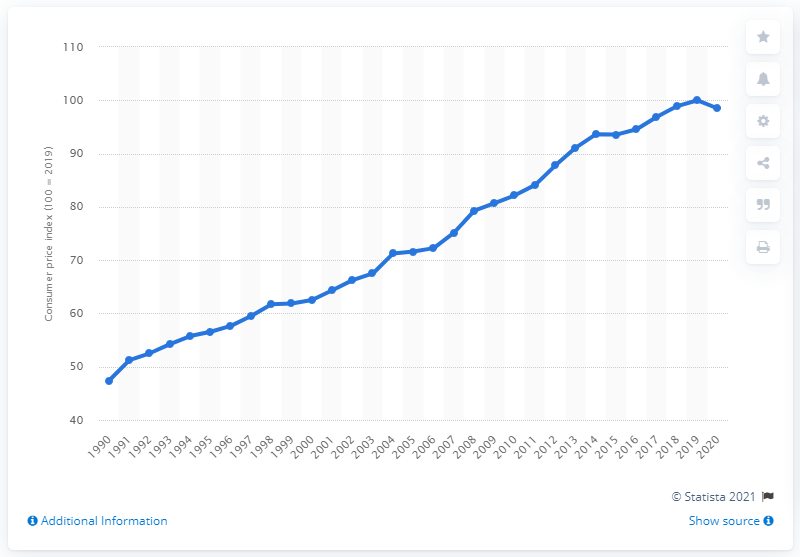Give some essential details in this illustration. The Consumer Price Index (CPI) for health care doubled in value between 1990 and . 